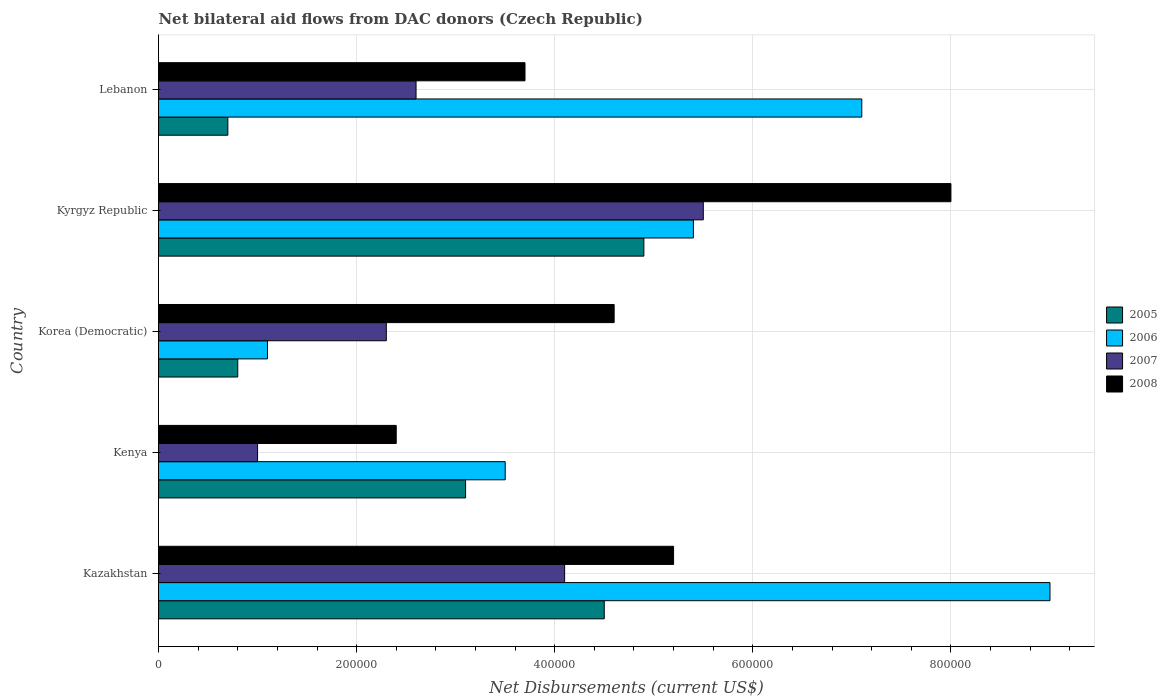Are the number of bars per tick equal to the number of legend labels?
Your answer should be very brief. Yes. Are the number of bars on each tick of the Y-axis equal?
Keep it short and to the point. Yes. How many bars are there on the 2nd tick from the top?
Ensure brevity in your answer.  4. How many bars are there on the 5th tick from the bottom?
Keep it short and to the point. 4. What is the label of the 3rd group of bars from the top?
Offer a terse response. Korea (Democratic). In how many cases, is the number of bars for a given country not equal to the number of legend labels?
Your answer should be compact. 0. Across all countries, what is the minimum net bilateral aid flows in 2008?
Your response must be concise. 2.40e+05. In which country was the net bilateral aid flows in 2008 maximum?
Provide a short and direct response. Kyrgyz Republic. In which country was the net bilateral aid flows in 2006 minimum?
Offer a very short reply. Korea (Democratic). What is the total net bilateral aid flows in 2007 in the graph?
Make the answer very short. 1.55e+06. What is the difference between the net bilateral aid flows in 2006 in Kyrgyz Republic and that in Lebanon?
Your response must be concise. -1.70e+05. What is the difference between the net bilateral aid flows in 2008 in Kenya and the net bilateral aid flows in 2007 in Lebanon?
Offer a very short reply. -2.00e+04. What is the average net bilateral aid flows in 2006 per country?
Offer a very short reply. 5.22e+05. In how many countries, is the net bilateral aid flows in 2005 greater than 560000 US$?
Provide a short and direct response. 0. What is the ratio of the net bilateral aid flows in 2007 in Kazakhstan to that in Kyrgyz Republic?
Make the answer very short. 0.75. Is the net bilateral aid flows in 2007 in Kenya less than that in Lebanon?
Make the answer very short. Yes. What is the difference between the highest and the second highest net bilateral aid flows in 2006?
Provide a short and direct response. 1.90e+05. In how many countries, is the net bilateral aid flows in 2006 greater than the average net bilateral aid flows in 2006 taken over all countries?
Your answer should be compact. 3. Is the sum of the net bilateral aid flows in 2005 in Kenya and Korea (Democratic) greater than the maximum net bilateral aid flows in 2007 across all countries?
Your response must be concise. No. What does the 3rd bar from the top in Kazakhstan represents?
Ensure brevity in your answer.  2006. What does the 1st bar from the bottom in Lebanon represents?
Your response must be concise. 2005. Are all the bars in the graph horizontal?
Give a very brief answer. Yes. How many countries are there in the graph?
Your response must be concise. 5. What is the difference between two consecutive major ticks on the X-axis?
Make the answer very short. 2.00e+05. Are the values on the major ticks of X-axis written in scientific E-notation?
Offer a very short reply. No. How many legend labels are there?
Give a very brief answer. 4. How are the legend labels stacked?
Provide a succinct answer. Vertical. What is the title of the graph?
Offer a very short reply. Net bilateral aid flows from DAC donors (Czech Republic). What is the label or title of the X-axis?
Your response must be concise. Net Disbursements (current US$). What is the Net Disbursements (current US$) of 2007 in Kazakhstan?
Ensure brevity in your answer.  4.10e+05. What is the Net Disbursements (current US$) in 2008 in Kazakhstan?
Give a very brief answer. 5.20e+05. What is the Net Disbursements (current US$) of 2006 in Kenya?
Your answer should be very brief. 3.50e+05. What is the Net Disbursements (current US$) in 2007 in Kenya?
Provide a succinct answer. 1.00e+05. What is the Net Disbursements (current US$) of 2005 in Korea (Democratic)?
Keep it short and to the point. 8.00e+04. What is the Net Disbursements (current US$) in 2007 in Korea (Democratic)?
Offer a very short reply. 2.30e+05. What is the Net Disbursements (current US$) in 2008 in Korea (Democratic)?
Your answer should be compact. 4.60e+05. What is the Net Disbursements (current US$) in 2005 in Kyrgyz Republic?
Offer a very short reply. 4.90e+05. What is the Net Disbursements (current US$) in 2006 in Kyrgyz Republic?
Provide a succinct answer. 5.40e+05. What is the Net Disbursements (current US$) in 2006 in Lebanon?
Offer a terse response. 7.10e+05. What is the Net Disbursements (current US$) of 2008 in Lebanon?
Ensure brevity in your answer.  3.70e+05. Across all countries, what is the maximum Net Disbursements (current US$) in 2005?
Give a very brief answer. 4.90e+05. Across all countries, what is the maximum Net Disbursements (current US$) of 2008?
Your answer should be compact. 8.00e+05. Across all countries, what is the minimum Net Disbursements (current US$) in 2005?
Your answer should be very brief. 7.00e+04. Across all countries, what is the minimum Net Disbursements (current US$) of 2006?
Offer a terse response. 1.10e+05. What is the total Net Disbursements (current US$) of 2005 in the graph?
Offer a terse response. 1.40e+06. What is the total Net Disbursements (current US$) in 2006 in the graph?
Make the answer very short. 2.61e+06. What is the total Net Disbursements (current US$) of 2007 in the graph?
Give a very brief answer. 1.55e+06. What is the total Net Disbursements (current US$) in 2008 in the graph?
Make the answer very short. 2.39e+06. What is the difference between the Net Disbursements (current US$) in 2006 in Kazakhstan and that in Kenya?
Keep it short and to the point. 5.50e+05. What is the difference between the Net Disbursements (current US$) of 2007 in Kazakhstan and that in Kenya?
Give a very brief answer. 3.10e+05. What is the difference between the Net Disbursements (current US$) of 2008 in Kazakhstan and that in Kenya?
Your answer should be very brief. 2.80e+05. What is the difference between the Net Disbursements (current US$) in 2005 in Kazakhstan and that in Korea (Democratic)?
Provide a succinct answer. 3.70e+05. What is the difference between the Net Disbursements (current US$) of 2006 in Kazakhstan and that in Korea (Democratic)?
Provide a short and direct response. 7.90e+05. What is the difference between the Net Disbursements (current US$) in 2007 in Kazakhstan and that in Korea (Democratic)?
Your response must be concise. 1.80e+05. What is the difference between the Net Disbursements (current US$) of 2008 in Kazakhstan and that in Korea (Democratic)?
Your answer should be compact. 6.00e+04. What is the difference between the Net Disbursements (current US$) of 2005 in Kazakhstan and that in Kyrgyz Republic?
Offer a very short reply. -4.00e+04. What is the difference between the Net Disbursements (current US$) in 2006 in Kazakhstan and that in Kyrgyz Republic?
Offer a very short reply. 3.60e+05. What is the difference between the Net Disbursements (current US$) in 2007 in Kazakhstan and that in Kyrgyz Republic?
Offer a terse response. -1.40e+05. What is the difference between the Net Disbursements (current US$) of 2008 in Kazakhstan and that in Kyrgyz Republic?
Offer a very short reply. -2.80e+05. What is the difference between the Net Disbursements (current US$) of 2005 in Kazakhstan and that in Lebanon?
Provide a succinct answer. 3.80e+05. What is the difference between the Net Disbursements (current US$) of 2008 in Kazakhstan and that in Lebanon?
Give a very brief answer. 1.50e+05. What is the difference between the Net Disbursements (current US$) of 2007 in Kenya and that in Korea (Democratic)?
Provide a succinct answer. -1.30e+05. What is the difference between the Net Disbursements (current US$) in 2005 in Kenya and that in Kyrgyz Republic?
Ensure brevity in your answer.  -1.80e+05. What is the difference between the Net Disbursements (current US$) of 2007 in Kenya and that in Kyrgyz Republic?
Make the answer very short. -4.50e+05. What is the difference between the Net Disbursements (current US$) of 2008 in Kenya and that in Kyrgyz Republic?
Provide a short and direct response. -5.60e+05. What is the difference between the Net Disbursements (current US$) of 2005 in Kenya and that in Lebanon?
Provide a short and direct response. 2.40e+05. What is the difference between the Net Disbursements (current US$) in 2006 in Kenya and that in Lebanon?
Your answer should be compact. -3.60e+05. What is the difference between the Net Disbursements (current US$) of 2007 in Kenya and that in Lebanon?
Your answer should be compact. -1.60e+05. What is the difference between the Net Disbursements (current US$) of 2008 in Kenya and that in Lebanon?
Keep it short and to the point. -1.30e+05. What is the difference between the Net Disbursements (current US$) in 2005 in Korea (Democratic) and that in Kyrgyz Republic?
Provide a short and direct response. -4.10e+05. What is the difference between the Net Disbursements (current US$) of 2006 in Korea (Democratic) and that in Kyrgyz Republic?
Make the answer very short. -4.30e+05. What is the difference between the Net Disbursements (current US$) of 2007 in Korea (Democratic) and that in Kyrgyz Republic?
Your response must be concise. -3.20e+05. What is the difference between the Net Disbursements (current US$) in 2008 in Korea (Democratic) and that in Kyrgyz Republic?
Keep it short and to the point. -3.40e+05. What is the difference between the Net Disbursements (current US$) of 2005 in Korea (Democratic) and that in Lebanon?
Your answer should be very brief. 10000. What is the difference between the Net Disbursements (current US$) in 2006 in Korea (Democratic) and that in Lebanon?
Keep it short and to the point. -6.00e+05. What is the difference between the Net Disbursements (current US$) in 2008 in Korea (Democratic) and that in Lebanon?
Offer a terse response. 9.00e+04. What is the difference between the Net Disbursements (current US$) in 2006 in Kyrgyz Republic and that in Lebanon?
Offer a very short reply. -1.70e+05. What is the difference between the Net Disbursements (current US$) of 2008 in Kyrgyz Republic and that in Lebanon?
Give a very brief answer. 4.30e+05. What is the difference between the Net Disbursements (current US$) of 2005 in Kazakhstan and the Net Disbursements (current US$) of 2006 in Kenya?
Give a very brief answer. 1.00e+05. What is the difference between the Net Disbursements (current US$) in 2005 in Kazakhstan and the Net Disbursements (current US$) in 2007 in Kenya?
Your answer should be compact. 3.50e+05. What is the difference between the Net Disbursements (current US$) in 2006 in Kazakhstan and the Net Disbursements (current US$) in 2008 in Kenya?
Give a very brief answer. 6.60e+05. What is the difference between the Net Disbursements (current US$) of 2007 in Kazakhstan and the Net Disbursements (current US$) of 2008 in Kenya?
Offer a very short reply. 1.70e+05. What is the difference between the Net Disbursements (current US$) in 2006 in Kazakhstan and the Net Disbursements (current US$) in 2007 in Korea (Democratic)?
Keep it short and to the point. 6.70e+05. What is the difference between the Net Disbursements (current US$) in 2005 in Kazakhstan and the Net Disbursements (current US$) in 2006 in Kyrgyz Republic?
Provide a succinct answer. -9.00e+04. What is the difference between the Net Disbursements (current US$) of 2005 in Kazakhstan and the Net Disbursements (current US$) of 2007 in Kyrgyz Republic?
Offer a very short reply. -1.00e+05. What is the difference between the Net Disbursements (current US$) of 2005 in Kazakhstan and the Net Disbursements (current US$) of 2008 in Kyrgyz Republic?
Keep it short and to the point. -3.50e+05. What is the difference between the Net Disbursements (current US$) of 2006 in Kazakhstan and the Net Disbursements (current US$) of 2007 in Kyrgyz Republic?
Offer a very short reply. 3.50e+05. What is the difference between the Net Disbursements (current US$) in 2007 in Kazakhstan and the Net Disbursements (current US$) in 2008 in Kyrgyz Republic?
Make the answer very short. -3.90e+05. What is the difference between the Net Disbursements (current US$) in 2005 in Kazakhstan and the Net Disbursements (current US$) in 2006 in Lebanon?
Offer a terse response. -2.60e+05. What is the difference between the Net Disbursements (current US$) of 2006 in Kazakhstan and the Net Disbursements (current US$) of 2007 in Lebanon?
Offer a very short reply. 6.40e+05. What is the difference between the Net Disbursements (current US$) in 2006 in Kazakhstan and the Net Disbursements (current US$) in 2008 in Lebanon?
Make the answer very short. 5.30e+05. What is the difference between the Net Disbursements (current US$) of 2007 in Kazakhstan and the Net Disbursements (current US$) of 2008 in Lebanon?
Provide a succinct answer. 4.00e+04. What is the difference between the Net Disbursements (current US$) in 2005 in Kenya and the Net Disbursements (current US$) in 2006 in Korea (Democratic)?
Give a very brief answer. 2.00e+05. What is the difference between the Net Disbursements (current US$) in 2005 in Kenya and the Net Disbursements (current US$) in 2007 in Korea (Democratic)?
Keep it short and to the point. 8.00e+04. What is the difference between the Net Disbursements (current US$) in 2005 in Kenya and the Net Disbursements (current US$) in 2008 in Korea (Democratic)?
Make the answer very short. -1.50e+05. What is the difference between the Net Disbursements (current US$) in 2007 in Kenya and the Net Disbursements (current US$) in 2008 in Korea (Democratic)?
Provide a short and direct response. -3.60e+05. What is the difference between the Net Disbursements (current US$) in 2005 in Kenya and the Net Disbursements (current US$) in 2008 in Kyrgyz Republic?
Provide a short and direct response. -4.90e+05. What is the difference between the Net Disbursements (current US$) in 2006 in Kenya and the Net Disbursements (current US$) in 2008 in Kyrgyz Republic?
Provide a short and direct response. -4.50e+05. What is the difference between the Net Disbursements (current US$) in 2007 in Kenya and the Net Disbursements (current US$) in 2008 in Kyrgyz Republic?
Your response must be concise. -7.00e+05. What is the difference between the Net Disbursements (current US$) in 2005 in Kenya and the Net Disbursements (current US$) in 2006 in Lebanon?
Offer a terse response. -4.00e+05. What is the difference between the Net Disbursements (current US$) in 2005 in Kenya and the Net Disbursements (current US$) in 2007 in Lebanon?
Your response must be concise. 5.00e+04. What is the difference between the Net Disbursements (current US$) in 2005 in Kenya and the Net Disbursements (current US$) in 2008 in Lebanon?
Offer a very short reply. -6.00e+04. What is the difference between the Net Disbursements (current US$) of 2006 in Kenya and the Net Disbursements (current US$) of 2007 in Lebanon?
Your response must be concise. 9.00e+04. What is the difference between the Net Disbursements (current US$) in 2006 in Kenya and the Net Disbursements (current US$) in 2008 in Lebanon?
Make the answer very short. -2.00e+04. What is the difference between the Net Disbursements (current US$) of 2007 in Kenya and the Net Disbursements (current US$) of 2008 in Lebanon?
Offer a very short reply. -2.70e+05. What is the difference between the Net Disbursements (current US$) of 2005 in Korea (Democratic) and the Net Disbursements (current US$) of 2006 in Kyrgyz Republic?
Provide a short and direct response. -4.60e+05. What is the difference between the Net Disbursements (current US$) of 2005 in Korea (Democratic) and the Net Disbursements (current US$) of 2007 in Kyrgyz Republic?
Give a very brief answer. -4.70e+05. What is the difference between the Net Disbursements (current US$) of 2005 in Korea (Democratic) and the Net Disbursements (current US$) of 2008 in Kyrgyz Republic?
Your response must be concise. -7.20e+05. What is the difference between the Net Disbursements (current US$) of 2006 in Korea (Democratic) and the Net Disbursements (current US$) of 2007 in Kyrgyz Republic?
Your answer should be compact. -4.40e+05. What is the difference between the Net Disbursements (current US$) in 2006 in Korea (Democratic) and the Net Disbursements (current US$) in 2008 in Kyrgyz Republic?
Provide a short and direct response. -6.90e+05. What is the difference between the Net Disbursements (current US$) of 2007 in Korea (Democratic) and the Net Disbursements (current US$) of 2008 in Kyrgyz Republic?
Give a very brief answer. -5.70e+05. What is the difference between the Net Disbursements (current US$) in 2005 in Korea (Democratic) and the Net Disbursements (current US$) in 2006 in Lebanon?
Keep it short and to the point. -6.30e+05. What is the difference between the Net Disbursements (current US$) in 2005 in Korea (Democratic) and the Net Disbursements (current US$) in 2008 in Lebanon?
Give a very brief answer. -2.90e+05. What is the difference between the Net Disbursements (current US$) in 2006 in Korea (Democratic) and the Net Disbursements (current US$) in 2007 in Lebanon?
Provide a succinct answer. -1.50e+05. What is the difference between the Net Disbursements (current US$) of 2005 in Kyrgyz Republic and the Net Disbursements (current US$) of 2007 in Lebanon?
Provide a short and direct response. 2.30e+05. What is the difference between the Net Disbursements (current US$) of 2005 in Kyrgyz Republic and the Net Disbursements (current US$) of 2008 in Lebanon?
Ensure brevity in your answer.  1.20e+05. What is the difference between the Net Disbursements (current US$) of 2006 in Kyrgyz Republic and the Net Disbursements (current US$) of 2007 in Lebanon?
Give a very brief answer. 2.80e+05. What is the difference between the Net Disbursements (current US$) of 2006 in Kyrgyz Republic and the Net Disbursements (current US$) of 2008 in Lebanon?
Give a very brief answer. 1.70e+05. What is the average Net Disbursements (current US$) of 2005 per country?
Provide a succinct answer. 2.80e+05. What is the average Net Disbursements (current US$) of 2006 per country?
Keep it short and to the point. 5.22e+05. What is the average Net Disbursements (current US$) of 2008 per country?
Make the answer very short. 4.78e+05. What is the difference between the Net Disbursements (current US$) of 2005 and Net Disbursements (current US$) of 2006 in Kazakhstan?
Provide a short and direct response. -4.50e+05. What is the difference between the Net Disbursements (current US$) in 2005 and Net Disbursements (current US$) in 2007 in Kazakhstan?
Your response must be concise. 4.00e+04. What is the difference between the Net Disbursements (current US$) of 2005 and Net Disbursements (current US$) of 2008 in Kazakhstan?
Offer a terse response. -7.00e+04. What is the difference between the Net Disbursements (current US$) of 2006 and Net Disbursements (current US$) of 2007 in Kazakhstan?
Ensure brevity in your answer.  4.90e+05. What is the difference between the Net Disbursements (current US$) of 2006 and Net Disbursements (current US$) of 2008 in Kazakhstan?
Make the answer very short. 3.80e+05. What is the difference between the Net Disbursements (current US$) of 2007 and Net Disbursements (current US$) of 2008 in Kazakhstan?
Offer a very short reply. -1.10e+05. What is the difference between the Net Disbursements (current US$) in 2005 and Net Disbursements (current US$) in 2006 in Kenya?
Ensure brevity in your answer.  -4.00e+04. What is the difference between the Net Disbursements (current US$) of 2005 and Net Disbursements (current US$) of 2008 in Korea (Democratic)?
Provide a short and direct response. -3.80e+05. What is the difference between the Net Disbursements (current US$) in 2006 and Net Disbursements (current US$) in 2008 in Korea (Democratic)?
Give a very brief answer. -3.50e+05. What is the difference between the Net Disbursements (current US$) in 2005 and Net Disbursements (current US$) in 2006 in Kyrgyz Republic?
Your response must be concise. -5.00e+04. What is the difference between the Net Disbursements (current US$) in 2005 and Net Disbursements (current US$) in 2007 in Kyrgyz Republic?
Ensure brevity in your answer.  -6.00e+04. What is the difference between the Net Disbursements (current US$) in 2005 and Net Disbursements (current US$) in 2008 in Kyrgyz Republic?
Keep it short and to the point. -3.10e+05. What is the difference between the Net Disbursements (current US$) of 2006 and Net Disbursements (current US$) of 2008 in Kyrgyz Republic?
Your answer should be very brief. -2.60e+05. What is the difference between the Net Disbursements (current US$) in 2005 and Net Disbursements (current US$) in 2006 in Lebanon?
Your answer should be very brief. -6.40e+05. What is the difference between the Net Disbursements (current US$) of 2006 and Net Disbursements (current US$) of 2008 in Lebanon?
Make the answer very short. 3.40e+05. What is the difference between the Net Disbursements (current US$) in 2007 and Net Disbursements (current US$) in 2008 in Lebanon?
Make the answer very short. -1.10e+05. What is the ratio of the Net Disbursements (current US$) in 2005 in Kazakhstan to that in Kenya?
Provide a succinct answer. 1.45. What is the ratio of the Net Disbursements (current US$) of 2006 in Kazakhstan to that in Kenya?
Provide a short and direct response. 2.57. What is the ratio of the Net Disbursements (current US$) of 2008 in Kazakhstan to that in Kenya?
Offer a very short reply. 2.17. What is the ratio of the Net Disbursements (current US$) of 2005 in Kazakhstan to that in Korea (Democratic)?
Provide a succinct answer. 5.62. What is the ratio of the Net Disbursements (current US$) of 2006 in Kazakhstan to that in Korea (Democratic)?
Keep it short and to the point. 8.18. What is the ratio of the Net Disbursements (current US$) of 2007 in Kazakhstan to that in Korea (Democratic)?
Your answer should be compact. 1.78. What is the ratio of the Net Disbursements (current US$) in 2008 in Kazakhstan to that in Korea (Democratic)?
Keep it short and to the point. 1.13. What is the ratio of the Net Disbursements (current US$) of 2005 in Kazakhstan to that in Kyrgyz Republic?
Your answer should be very brief. 0.92. What is the ratio of the Net Disbursements (current US$) of 2007 in Kazakhstan to that in Kyrgyz Republic?
Provide a short and direct response. 0.75. What is the ratio of the Net Disbursements (current US$) in 2008 in Kazakhstan to that in Kyrgyz Republic?
Keep it short and to the point. 0.65. What is the ratio of the Net Disbursements (current US$) of 2005 in Kazakhstan to that in Lebanon?
Your answer should be compact. 6.43. What is the ratio of the Net Disbursements (current US$) of 2006 in Kazakhstan to that in Lebanon?
Your answer should be compact. 1.27. What is the ratio of the Net Disbursements (current US$) in 2007 in Kazakhstan to that in Lebanon?
Provide a short and direct response. 1.58. What is the ratio of the Net Disbursements (current US$) of 2008 in Kazakhstan to that in Lebanon?
Keep it short and to the point. 1.41. What is the ratio of the Net Disbursements (current US$) of 2005 in Kenya to that in Korea (Democratic)?
Make the answer very short. 3.88. What is the ratio of the Net Disbursements (current US$) of 2006 in Kenya to that in Korea (Democratic)?
Your answer should be compact. 3.18. What is the ratio of the Net Disbursements (current US$) of 2007 in Kenya to that in Korea (Democratic)?
Offer a terse response. 0.43. What is the ratio of the Net Disbursements (current US$) of 2008 in Kenya to that in Korea (Democratic)?
Make the answer very short. 0.52. What is the ratio of the Net Disbursements (current US$) of 2005 in Kenya to that in Kyrgyz Republic?
Offer a very short reply. 0.63. What is the ratio of the Net Disbursements (current US$) in 2006 in Kenya to that in Kyrgyz Republic?
Offer a terse response. 0.65. What is the ratio of the Net Disbursements (current US$) of 2007 in Kenya to that in Kyrgyz Republic?
Make the answer very short. 0.18. What is the ratio of the Net Disbursements (current US$) in 2008 in Kenya to that in Kyrgyz Republic?
Give a very brief answer. 0.3. What is the ratio of the Net Disbursements (current US$) in 2005 in Kenya to that in Lebanon?
Offer a very short reply. 4.43. What is the ratio of the Net Disbursements (current US$) of 2006 in Kenya to that in Lebanon?
Offer a very short reply. 0.49. What is the ratio of the Net Disbursements (current US$) in 2007 in Kenya to that in Lebanon?
Provide a succinct answer. 0.38. What is the ratio of the Net Disbursements (current US$) of 2008 in Kenya to that in Lebanon?
Provide a succinct answer. 0.65. What is the ratio of the Net Disbursements (current US$) of 2005 in Korea (Democratic) to that in Kyrgyz Republic?
Offer a very short reply. 0.16. What is the ratio of the Net Disbursements (current US$) in 2006 in Korea (Democratic) to that in Kyrgyz Republic?
Ensure brevity in your answer.  0.2. What is the ratio of the Net Disbursements (current US$) of 2007 in Korea (Democratic) to that in Kyrgyz Republic?
Your response must be concise. 0.42. What is the ratio of the Net Disbursements (current US$) of 2008 in Korea (Democratic) to that in Kyrgyz Republic?
Ensure brevity in your answer.  0.57. What is the ratio of the Net Disbursements (current US$) in 2005 in Korea (Democratic) to that in Lebanon?
Provide a succinct answer. 1.14. What is the ratio of the Net Disbursements (current US$) of 2006 in Korea (Democratic) to that in Lebanon?
Offer a very short reply. 0.15. What is the ratio of the Net Disbursements (current US$) of 2007 in Korea (Democratic) to that in Lebanon?
Your response must be concise. 0.88. What is the ratio of the Net Disbursements (current US$) of 2008 in Korea (Democratic) to that in Lebanon?
Your answer should be compact. 1.24. What is the ratio of the Net Disbursements (current US$) of 2006 in Kyrgyz Republic to that in Lebanon?
Ensure brevity in your answer.  0.76. What is the ratio of the Net Disbursements (current US$) of 2007 in Kyrgyz Republic to that in Lebanon?
Offer a very short reply. 2.12. What is the ratio of the Net Disbursements (current US$) in 2008 in Kyrgyz Republic to that in Lebanon?
Offer a terse response. 2.16. What is the difference between the highest and the second highest Net Disbursements (current US$) in 2008?
Provide a short and direct response. 2.80e+05. What is the difference between the highest and the lowest Net Disbursements (current US$) of 2006?
Provide a short and direct response. 7.90e+05. What is the difference between the highest and the lowest Net Disbursements (current US$) in 2008?
Your answer should be very brief. 5.60e+05. 